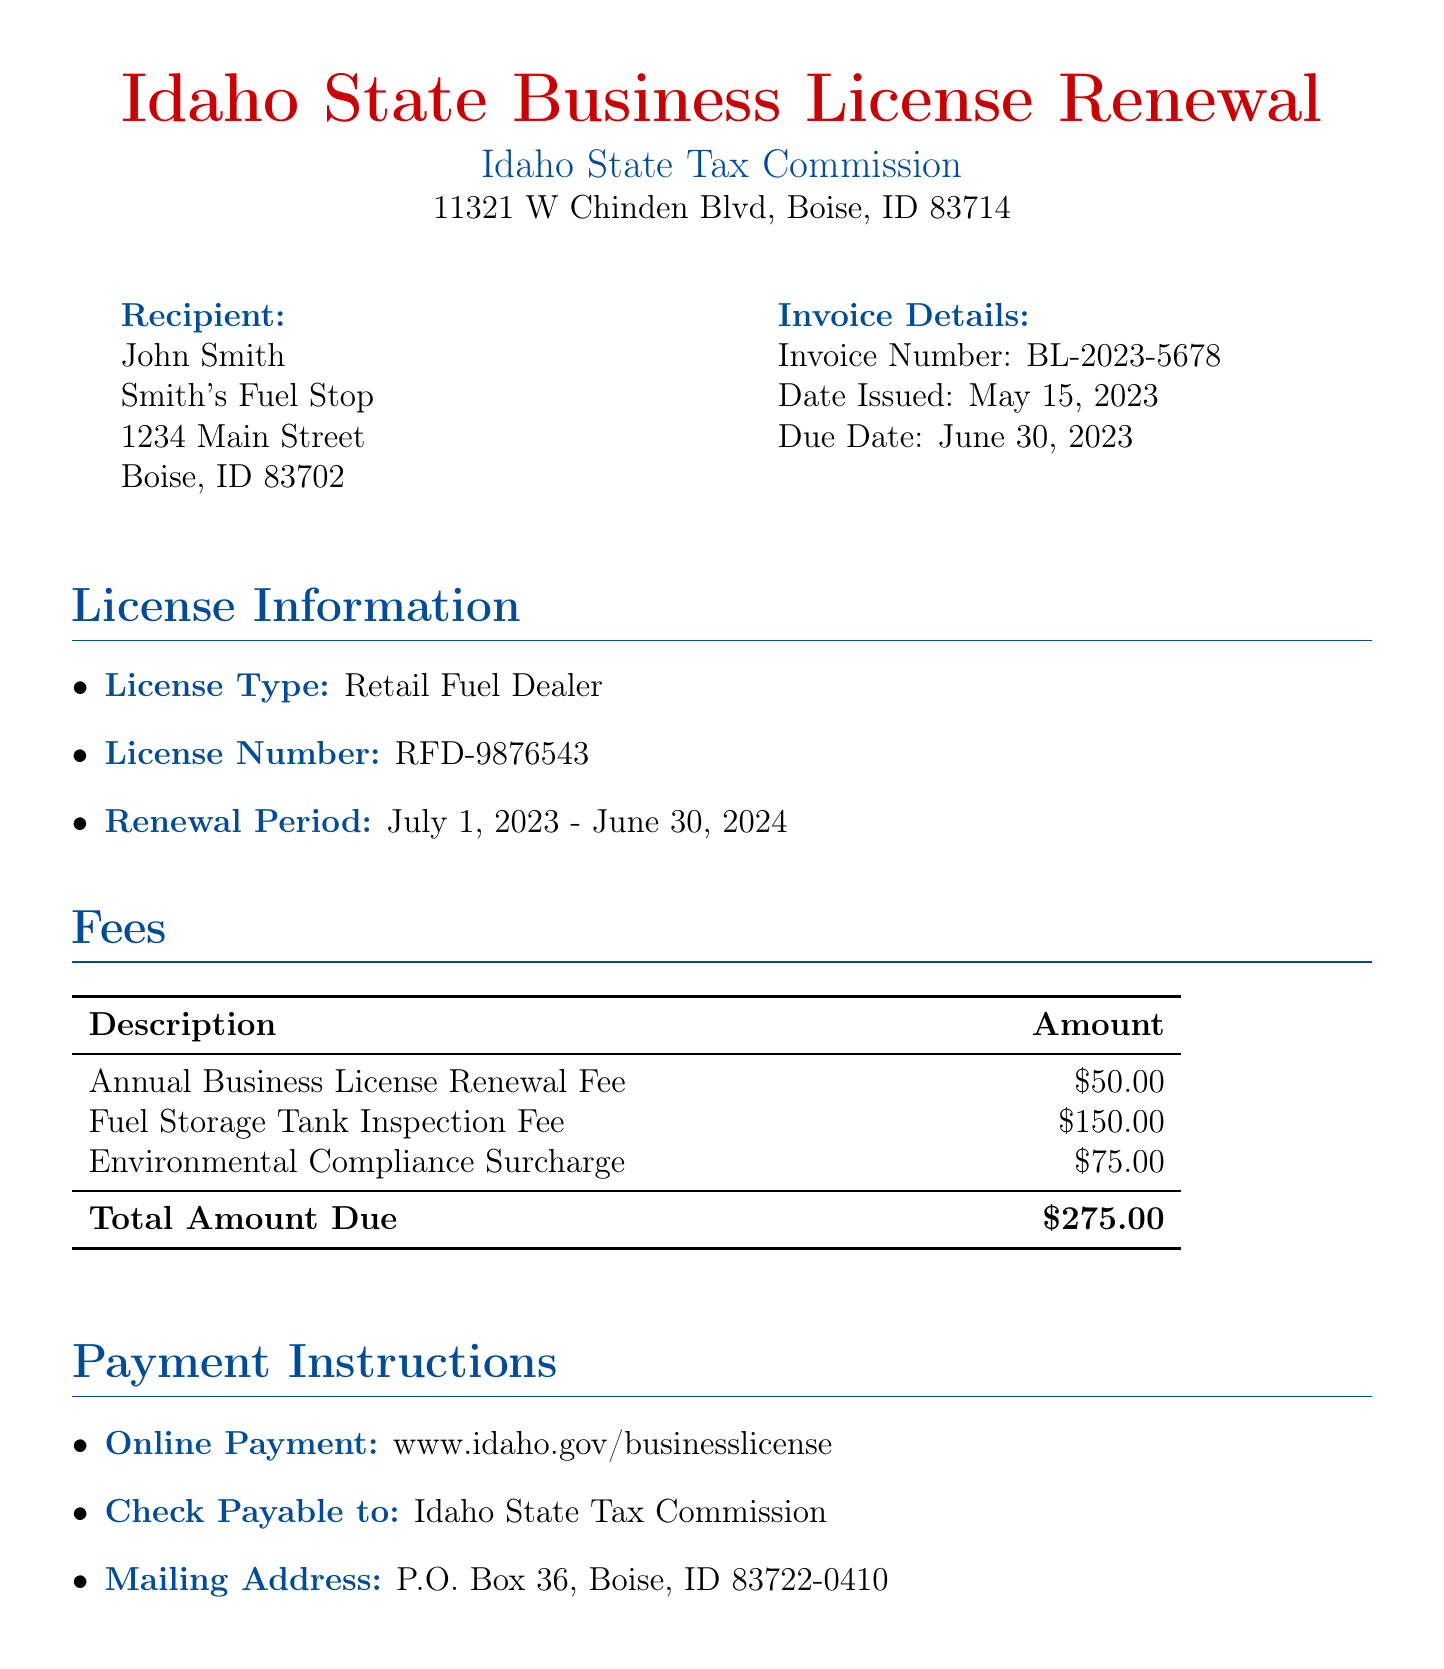What is the due date for the invoice? The due date for the invoice is specified in the document as June 30, 2023.
Answer: June 30, 2023 What is the total amount due? The total amount due is calculated and listed in the fees section of the document.
Answer: $275.00 Who is the recipient of the invoice? The recipient of the invoice is mentioned at the beginning of the document, detailing the name and organization.
Answer: John Smith What is the period of the license renewal? The renewal period is stated in the license information section, covering specific dates.
Answer: July 1, 2023 - June 30, 2024 What fee is associated with the fuel storage tank inspection? The specific fee for the fuel storage tank inspection is outlined in the fees table of the document.
Answer: $150.00 What is the mailing address for payment? The mailing address for payment is provided under the payment instructions in the document.
Answer: P.O. Box 36, Boise, ID 83722-0410 What is the license type mentioned in the invoice? The license type is identified in the license information section of the document.
Answer: Retail Fuel Dealer What will happen if payment is received late? The document specifies what occurs if payment is not made by the due date, highlighting any potential fees.
Answer: A $25 late fee will be applied How can payments be made online? The document mentions the website where payments can be made, indicating the method for online transactions.
Answer: www.idaho.gov/businesslicense 